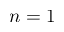Convert formula to latex. <formula><loc_0><loc_0><loc_500><loc_500>n = 1</formula> 